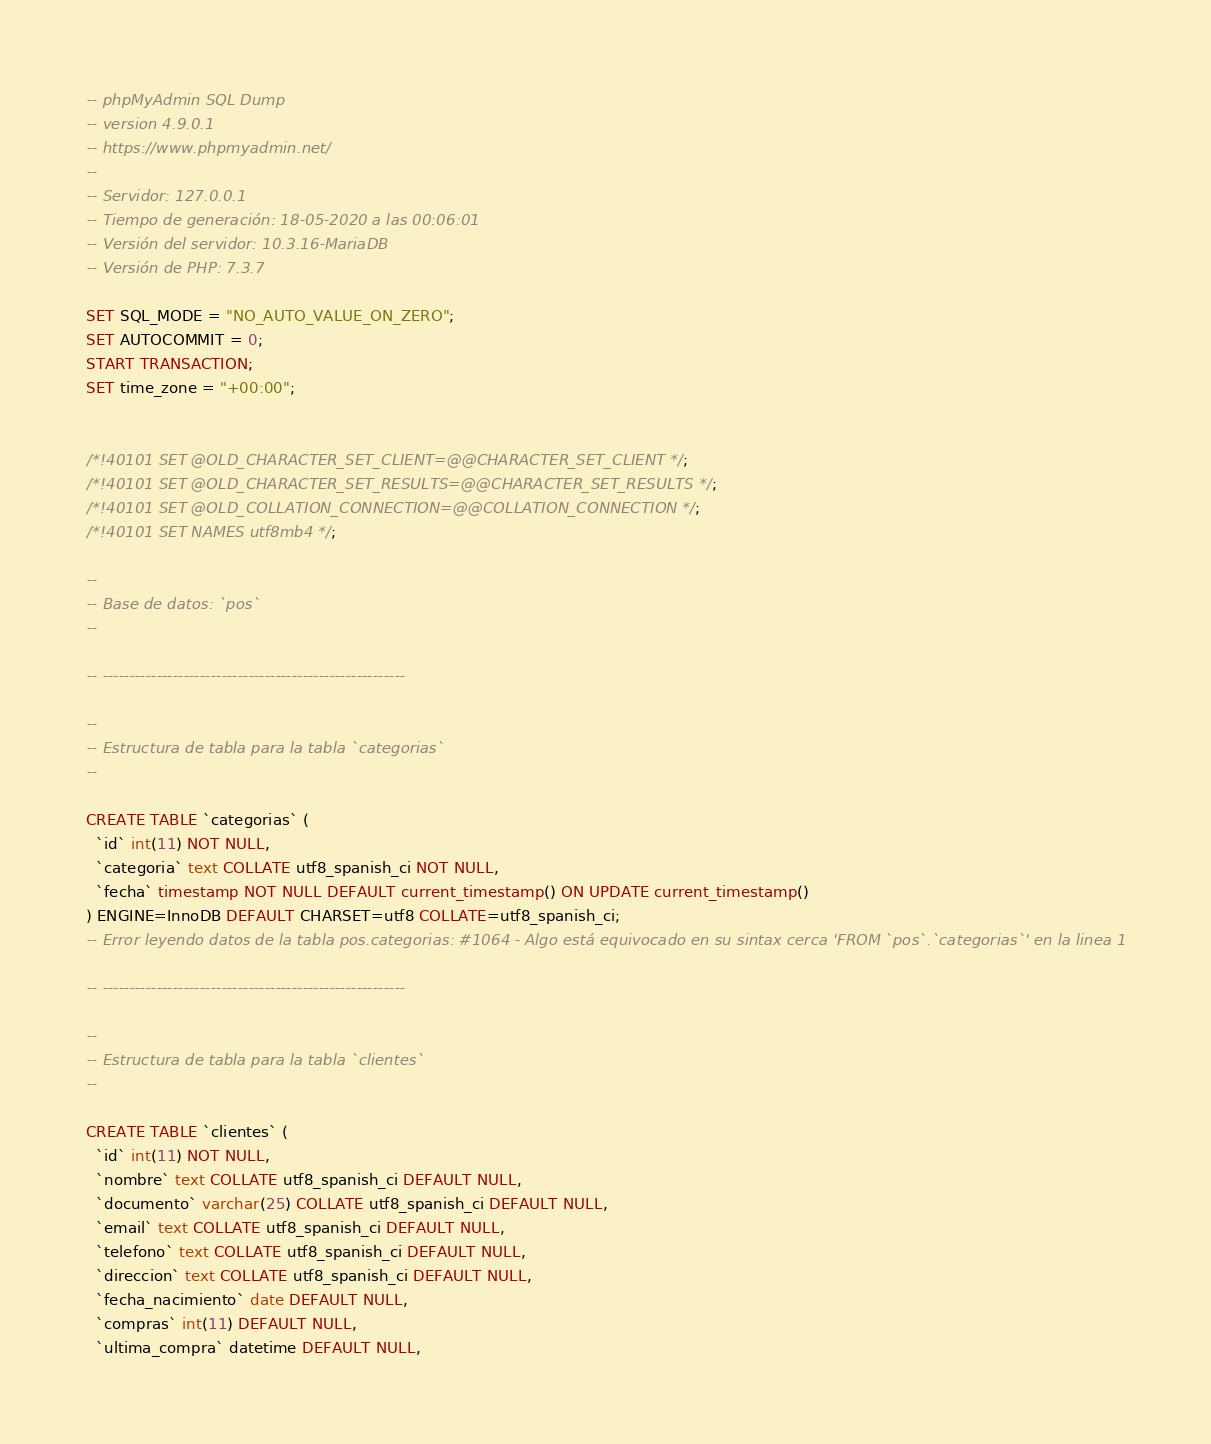<code> <loc_0><loc_0><loc_500><loc_500><_SQL_>-- phpMyAdmin SQL Dump
-- version 4.9.0.1
-- https://www.phpmyadmin.net/
--
-- Servidor: 127.0.0.1
-- Tiempo de generación: 18-05-2020 a las 00:06:01
-- Versión del servidor: 10.3.16-MariaDB
-- Versión de PHP: 7.3.7

SET SQL_MODE = "NO_AUTO_VALUE_ON_ZERO";
SET AUTOCOMMIT = 0;
START TRANSACTION;
SET time_zone = "+00:00";


/*!40101 SET @OLD_CHARACTER_SET_CLIENT=@@CHARACTER_SET_CLIENT */;
/*!40101 SET @OLD_CHARACTER_SET_RESULTS=@@CHARACTER_SET_RESULTS */;
/*!40101 SET @OLD_COLLATION_CONNECTION=@@COLLATION_CONNECTION */;
/*!40101 SET NAMES utf8mb4 */;

--
-- Base de datos: `pos`
--

-- --------------------------------------------------------

--
-- Estructura de tabla para la tabla `categorias`
--

CREATE TABLE `categorias` (
  `id` int(11) NOT NULL,
  `categoria` text COLLATE utf8_spanish_ci NOT NULL,
  `fecha` timestamp NOT NULL DEFAULT current_timestamp() ON UPDATE current_timestamp()
) ENGINE=InnoDB DEFAULT CHARSET=utf8 COLLATE=utf8_spanish_ci;
-- Error leyendo datos de la tabla pos.categorias: #1064 - Algo está equivocado en su sintax cerca 'FROM `pos`.`categorias`' en la linea 1

-- --------------------------------------------------------

--
-- Estructura de tabla para la tabla `clientes`
--

CREATE TABLE `clientes` (
  `id` int(11) NOT NULL,
  `nombre` text COLLATE utf8_spanish_ci DEFAULT NULL,
  `documento` varchar(25) COLLATE utf8_spanish_ci DEFAULT NULL,
  `email` text COLLATE utf8_spanish_ci DEFAULT NULL,
  `telefono` text COLLATE utf8_spanish_ci DEFAULT NULL,
  `direccion` text COLLATE utf8_spanish_ci DEFAULT NULL,
  `fecha_nacimiento` date DEFAULT NULL,
  `compras` int(11) DEFAULT NULL,
  `ultima_compra` datetime DEFAULT NULL,</code> 